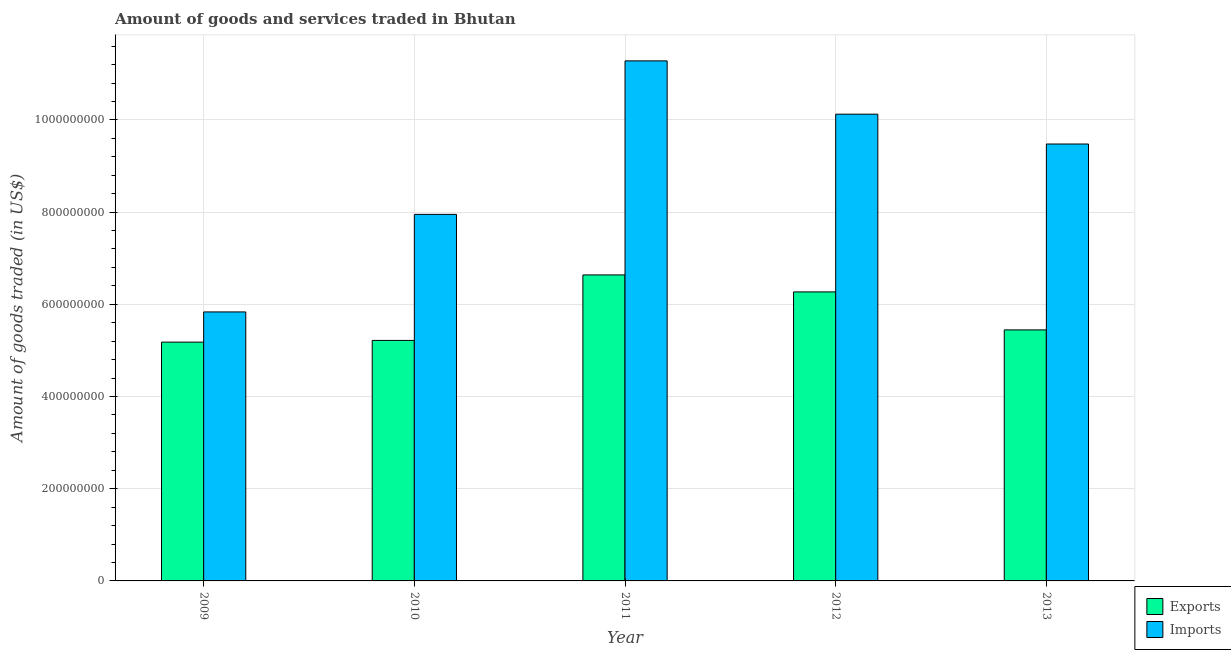How many different coloured bars are there?
Offer a terse response. 2. How many groups of bars are there?
Provide a short and direct response. 5. Are the number of bars per tick equal to the number of legend labels?
Provide a short and direct response. Yes. Are the number of bars on each tick of the X-axis equal?
Give a very brief answer. Yes. What is the amount of goods exported in 2010?
Offer a terse response. 5.22e+08. Across all years, what is the maximum amount of goods exported?
Offer a terse response. 6.64e+08. Across all years, what is the minimum amount of goods exported?
Your response must be concise. 5.18e+08. In which year was the amount of goods exported minimum?
Ensure brevity in your answer.  2009. What is the total amount of goods exported in the graph?
Ensure brevity in your answer.  2.87e+09. What is the difference between the amount of goods exported in 2010 and that in 2011?
Provide a succinct answer. -1.42e+08. What is the difference between the amount of goods imported in 2013 and the amount of goods exported in 2010?
Your response must be concise. 1.53e+08. What is the average amount of goods imported per year?
Offer a terse response. 8.93e+08. In the year 2011, what is the difference between the amount of goods exported and amount of goods imported?
Provide a short and direct response. 0. In how many years, is the amount of goods exported greater than 1000000000 US$?
Make the answer very short. 0. What is the ratio of the amount of goods exported in 2009 to that in 2012?
Your response must be concise. 0.83. Is the amount of goods imported in 2009 less than that in 2012?
Your answer should be very brief. Yes. Is the difference between the amount of goods imported in 2009 and 2013 greater than the difference between the amount of goods exported in 2009 and 2013?
Offer a very short reply. No. What is the difference between the highest and the second highest amount of goods imported?
Keep it short and to the point. 1.16e+08. What is the difference between the highest and the lowest amount of goods exported?
Your answer should be very brief. 1.46e+08. What does the 2nd bar from the left in 2009 represents?
Your answer should be very brief. Imports. What does the 2nd bar from the right in 2012 represents?
Provide a short and direct response. Exports. How many bars are there?
Keep it short and to the point. 10. Are the values on the major ticks of Y-axis written in scientific E-notation?
Provide a short and direct response. No. Does the graph contain any zero values?
Give a very brief answer. No. How are the legend labels stacked?
Provide a succinct answer. Vertical. What is the title of the graph?
Your answer should be compact. Amount of goods and services traded in Bhutan. What is the label or title of the X-axis?
Give a very brief answer. Year. What is the label or title of the Y-axis?
Offer a very short reply. Amount of goods traded (in US$). What is the Amount of goods traded (in US$) of Exports in 2009?
Give a very brief answer. 5.18e+08. What is the Amount of goods traded (in US$) of Imports in 2009?
Make the answer very short. 5.83e+08. What is the Amount of goods traded (in US$) in Exports in 2010?
Give a very brief answer. 5.22e+08. What is the Amount of goods traded (in US$) in Imports in 2010?
Offer a terse response. 7.95e+08. What is the Amount of goods traded (in US$) in Exports in 2011?
Give a very brief answer. 6.64e+08. What is the Amount of goods traded (in US$) in Imports in 2011?
Provide a succinct answer. 1.13e+09. What is the Amount of goods traded (in US$) in Exports in 2012?
Provide a succinct answer. 6.27e+08. What is the Amount of goods traded (in US$) of Imports in 2012?
Offer a terse response. 1.01e+09. What is the Amount of goods traded (in US$) in Exports in 2013?
Give a very brief answer. 5.44e+08. What is the Amount of goods traded (in US$) in Imports in 2013?
Your response must be concise. 9.48e+08. Across all years, what is the maximum Amount of goods traded (in US$) of Exports?
Your answer should be compact. 6.64e+08. Across all years, what is the maximum Amount of goods traded (in US$) in Imports?
Keep it short and to the point. 1.13e+09. Across all years, what is the minimum Amount of goods traded (in US$) in Exports?
Your answer should be very brief. 5.18e+08. Across all years, what is the minimum Amount of goods traded (in US$) of Imports?
Your answer should be compact. 5.83e+08. What is the total Amount of goods traded (in US$) of Exports in the graph?
Provide a succinct answer. 2.87e+09. What is the total Amount of goods traded (in US$) in Imports in the graph?
Keep it short and to the point. 4.47e+09. What is the difference between the Amount of goods traded (in US$) of Exports in 2009 and that in 2010?
Keep it short and to the point. -3.70e+06. What is the difference between the Amount of goods traded (in US$) in Imports in 2009 and that in 2010?
Give a very brief answer. -2.12e+08. What is the difference between the Amount of goods traded (in US$) of Exports in 2009 and that in 2011?
Your response must be concise. -1.46e+08. What is the difference between the Amount of goods traded (in US$) of Imports in 2009 and that in 2011?
Your answer should be compact. -5.45e+08. What is the difference between the Amount of goods traded (in US$) in Exports in 2009 and that in 2012?
Keep it short and to the point. -1.09e+08. What is the difference between the Amount of goods traded (in US$) in Imports in 2009 and that in 2012?
Offer a very short reply. -4.29e+08. What is the difference between the Amount of goods traded (in US$) in Exports in 2009 and that in 2013?
Ensure brevity in your answer.  -2.65e+07. What is the difference between the Amount of goods traded (in US$) in Imports in 2009 and that in 2013?
Offer a terse response. -3.64e+08. What is the difference between the Amount of goods traded (in US$) in Exports in 2010 and that in 2011?
Provide a short and direct response. -1.42e+08. What is the difference between the Amount of goods traded (in US$) in Imports in 2010 and that in 2011?
Give a very brief answer. -3.33e+08. What is the difference between the Amount of goods traded (in US$) in Exports in 2010 and that in 2012?
Provide a succinct answer. -1.05e+08. What is the difference between the Amount of goods traded (in US$) in Imports in 2010 and that in 2012?
Your answer should be compact. -2.17e+08. What is the difference between the Amount of goods traded (in US$) of Exports in 2010 and that in 2013?
Offer a terse response. -2.28e+07. What is the difference between the Amount of goods traded (in US$) of Imports in 2010 and that in 2013?
Keep it short and to the point. -1.53e+08. What is the difference between the Amount of goods traded (in US$) of Exports in 2011 and that in 2012?
Your answer should be compact. 3.68e+07. What is the difference between the Amount of goods traded (in US$) in Imports in 2011 and that in 2012?
Keep it short and to the point. 1.16e+08. What is the difference between the Amount of goods traded (in US$) of Exports in 2011 and that in 2013?
Make the answer very short. 1.19e+08. What is the difference between the Amount of goods traded (in US$) in Imports in 2011 and that in 2013?
Make the answer very short. 1.80e+08. What is the difference between the Amount of goods traded (in US$) in Exports in 2012 and that in 2013?
Your answer should be compact. 8.24e+07. What is the difference between the Amount of goods traded (in US$) of Imports in 2012 and that in 2013?
Offer a very short reply. 6.47e+07. What is the difference between the Amount of goods traded (in US$) of Exports in 2009 and the Amount of goods traded (in US$) of Imports in 2010?
Offer a very short reply. -2.77e+08. What is the difference between the Amount of goods traded (in US$) in Exports in 2009 and the Amount of goods traded (in US$) in Imports in 2011?
Keep it short and to the point. -6.10e+08. What is the difference between the Amount of goods traded (in US$) of Exports in 2009 and the Amount of goods traded (in US$) of Imports in 2012?
Your answer should be compact. -4.94e+08. What is the difference between the Amount of goods traded (in US$) of Exports in 2009 and the Amount of goods traded (in US$) of Imports in 2013?
Your response must be concise. -4.30e+08. What is the difference between the Amount of goods traded (in US$) of Exports in 2010 and the Amount of goods traded (in US$) of Imports in 2011?
Your answer should be compact. -6.06e+08. What is the difference between the Amount of goods traded (in US$) in Exports in 2010 and the Amount of goods traded (in US$) in Imports in 2012?
Provide a short and direct response. -4.91e+08. What is the difference between the Amount of goods traded (in US$) of Exports in 2010 and the Amount of goods traded (in US$) of Imports in 2013?
Make the answer very short. -4.26e+08. What is the difference between the Amount of goods traded (in US$) in Exports in 2011 and the Amount of goods traded (in US$) in Imports in 2012?
Offer a terse response. -3.49e+08. What is the difference between the Amount of goods traded (in US$) of Exports in 2011 and the Amount of goods traded (in US$) of Imports in 2013?
Your answer should be very brief. -2.84e+08. What is the difference between the Amount of goods traded (in US$) of Exports in 2012 and the Amount of goods traded (in US$) of Imports in 2013?
Provide a succinct answer. -3.21e+08. What is the average Amount of goods traded (in US$) in Exports per year?
Keep it short and to the point. 5.75e+08. What is the average Amount of goods traded (in US$) in Imports per year?
Make the answer very short. 8.93e+08. In the year 2009, what is the difference between the Amount of goods traded (in US$) in Exports and Amount of goods traded (in US$) in Imports?
Provide a short and direct response. -6.55e+07. In the year 2010, what is the difference between the Amount of goods traded (in US$) of Exports and Amount of goods traded (in US$) of Imports?
Provide a short and direct response. -2.73e+08. In the year 2011, what is the difference between the Amount of goods traded (in US$) in Exports and Amount of goods traded (in US$) in Imports?
Keep it short and to the point. -4.64e+08. In the year 2012, what is the difference between the Amount of goods traded (in US$) of Exports and Amount of goods traded (in US$) of Imports?
Your answer should be compact. -3.86e+08. In the year 2013, what is the difference between the Amount of goods traded (in US$) of Exports and Amount of goods traded (in US$) of Imports?
Offer a very short reply. -4.03e+08. What is the ratio of the Amount of goods traded (in US$) in Exports in 2009 to that in 2010?
Your answer should be very brief. 0.99. What is the ratio of the Amount of goods traded (in US$) of Imports in 2009 to that in 2010?
Give a very brief answer. 0.73. What is the ratio of the Amount of goods traded (in US$) of Exports in 2009 to that in 2011?
Your answer should be very brief. 0.78. What is the ratio of the Amount of goods traded (in US$) in Imports in 2009 to that in 2011?
Ensure brevity in your answer.  0.52. What is the ratio of the Amount of goods traded (in US$) in Exports in 2009 to that in 2012?
Offer a terse response. 0.83. What is the ratio of the Amount of goods traded (in US$) of Imports in 2009 to that in 2012?
Ensure brevity in your answer.  0.58. What is the ratio of the Amount of goods traded (in US$) in Exports in 2009 to that in 2013?
Make the answer very short. 0.95. What is the ratio of the Amount of goods traded (in US$) of Imports in 2009 to that in 2013?
Offer a terse response. 0.62. What is the ratio of the Amount of goods traded (in US$) in Exports in 2010 to that in 2011?
Offer a terse response. 0.79. What is the ratio of the Amount of goods traded (in US$) in Imports in 2010 to that in 2011?
Offer a terse response. 0.7. What is the ratio of the Amount of goods traded (in US$) of Exports in 2010 to that in 2012?
Provide a succinct answer. 0.83. What is the ratio of the Amount of goods traded (in US$) in Imports in 2010 to that in 2012?
Your answer should be compact. 0.79. What is the ratio of the Amount of goods traded (in US$) in Exports in 2010 to that in 2013?
Give a very brief answer. 0.96. What is the ratio of the Amount of goods traded (in US$) in Imports in 2010 to that in 2013?
Offer a terse response. 0.84. What is the ratio of the Amount of goods traded (in US$) in Exports in 2011 to that in 2012?
Offer a terse response. 1.06. What is the ratio of the Amount of goods traded (in US$) of Imports in 2011 to that in 2012?
Make the answer very short. 1.11. What is the ratio of the Amount of goods traded (in US$) of Exports in 2011 to that in 2013?
Provide a short and direct response. 1.22. What is the ratio of the Amount of goods traded (in US$) in Imports in 2011 to that in 2013?
Keep it short and to the point. 1.19. What is the ratio of the Amount of goods traded (in US$) of Exports in 2012 to that in 2013?
Provide a succinct answer. 1.15. What is the ratio of the Amount of goods traded (in US$) in Imports in 2012 to that in 2013?
Your answer should be very brief. 1.07. What is the difference between the highest and the second highest Amount of goods traded (in US$) in Exports?
Make the answer very short. 3.68e+07. What is the difference between the highest and the second highest Amount of goods traded (in US$) of Imports?
Make the answer very short. 1.16e+08. What is the difference between the highest and the lowest Amount of goods traded (in US$) of Exports?
Offer a very short reply. 1.46e+08. What is the difference between the highest and the lowest Amount of goods traded (in US$) in Imports?
Provide a succinct answer. 5.45e+08. 